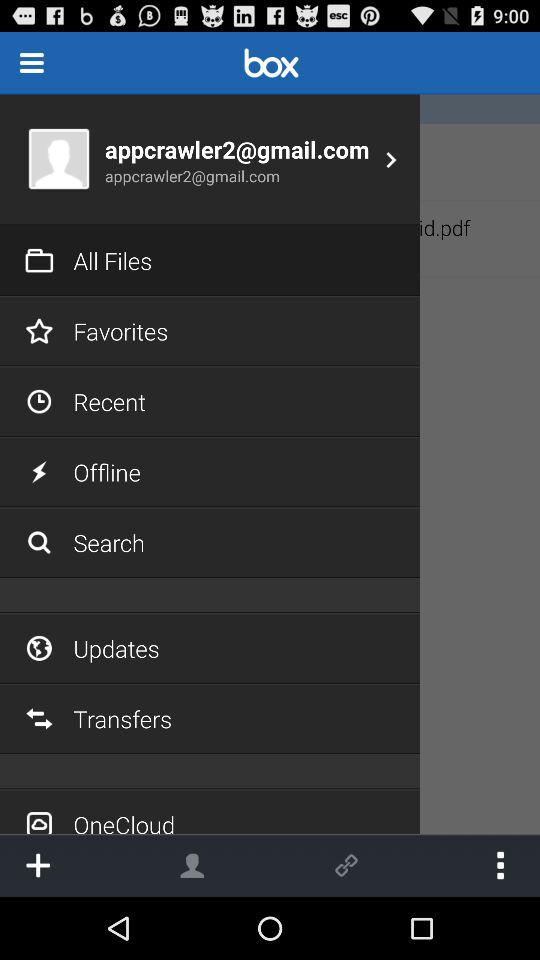How many files are in the All Files folder?
Answer the question using a single word or phrase. 2 